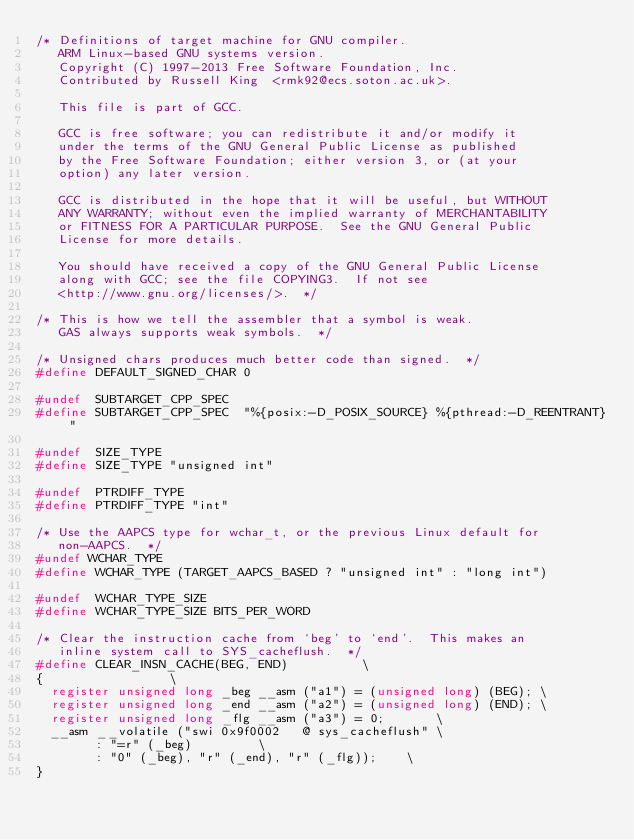<code> <loc_0><loc_0><loc_500><loc_500><_C_>/* Definitions of target machine for GNU compiler.
   ARM Linux-based GNU systems version.
   Copyright (C) 1997-2013 Free Software Foundation, Inc.
   Contributed by Russell King  <rmk92@ecs.soton.ac.uk>.

   This file is part of GCC.

   GCC is free software; you can redistribute it and/or modify it
   under the terms of the GNU General Public License as published
   by the Free Software Foundation; either version 3, or (at your
   option) any later version.

   GCC is distributed in the hope that it will be useful, but WITHOUT
   ANY WARRANTY; without even the implied warranty of MERCHANTABILITY
   or FITNESS FOR A PARTICULAR PURPOSE.  See the GNU General Public
   License for more details.

   You should have received a copy of the GNU General Public License
   along with GCC; see the file COPYING3.  If not see
   <http://www.gnu.org/licenses/>.  */

/* This is how we tell the assembler that a symbol is weak.
   GAS always supports weak symbols.  */

/* Unsigned chars produces much better code than signed.  */
#define DEFAULT_SIGNED_CHAR 0

#undef  SUBTARGET_CPP_SPEC
#define SUBTARGET_CPP_SPEC  "%{posix:-D_POSIX_SOURCE} %{pthread:-D_REENTRANT}"

#undef  SIZE_TYPE
#define SIZE_TYPE "unsigned int"

#undef  PTRDIFF_TYPE
#define PTRDIFF_TYPE "int"

/* Use the AAPCS type for wchar_t, or the previous Linux default for
   non-AAPCS.  */
#undef WCHAR_TYPE
#define WCHAR_TYPE (TARGET_AAPCS_BASED ? "unsigned int" : "long int")

#undef  WCHAR_TYPE_SIZE
#define WCHAR_TYPE_SIZE BITS_PER_WORD

/* Clear the instruction cache from `beg' to `end'.  This makes an
   inline system call to SYS_cacheflush.  */
#define CLEAR_INSN_CACHE(BEG, END)					\
{									\
  register unsigned long _beg __asm ("a1") = (unsigned long) (BEG);	\
  register unsigned long _end __asm ("a2") = (unsigned long) (END);	\
  register unsigned long _flg __asm ("a3") = 0;				\
  __asm __volatile ("swi 0x9f0002		@ sys_cacheflush"	\
		    : "=r" (_beg)					\
		    : "0" (_beg), "r" (_end), "r" (_flg));		\
}
</code> 